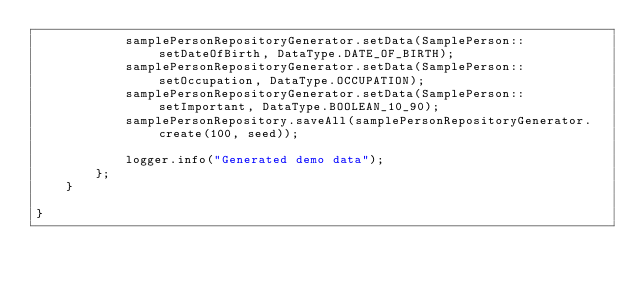Convert code to text. <code><loc_0><loc_0><loc_500><loc_500><_Java_>            samplePersonRepositoryGenerator.setData(SamplePerson::setDateOfBirth, DataType.DATE_OF_BIRTH);
            samplePersonRepositoryGenerator.setData(SamplePerson::setOccupation, DataType.OCCUPATION);
            samplePersonRepositoryGenerator.setData(SamplePerson::setImportant, DataType.BOOLEAN_10_90);
            samplePersonRepository.saveAll(samplePersonRepositoryGenerator.create(100, seed));

            logger.info("Generated demo data");
        };
    }

}</code> 